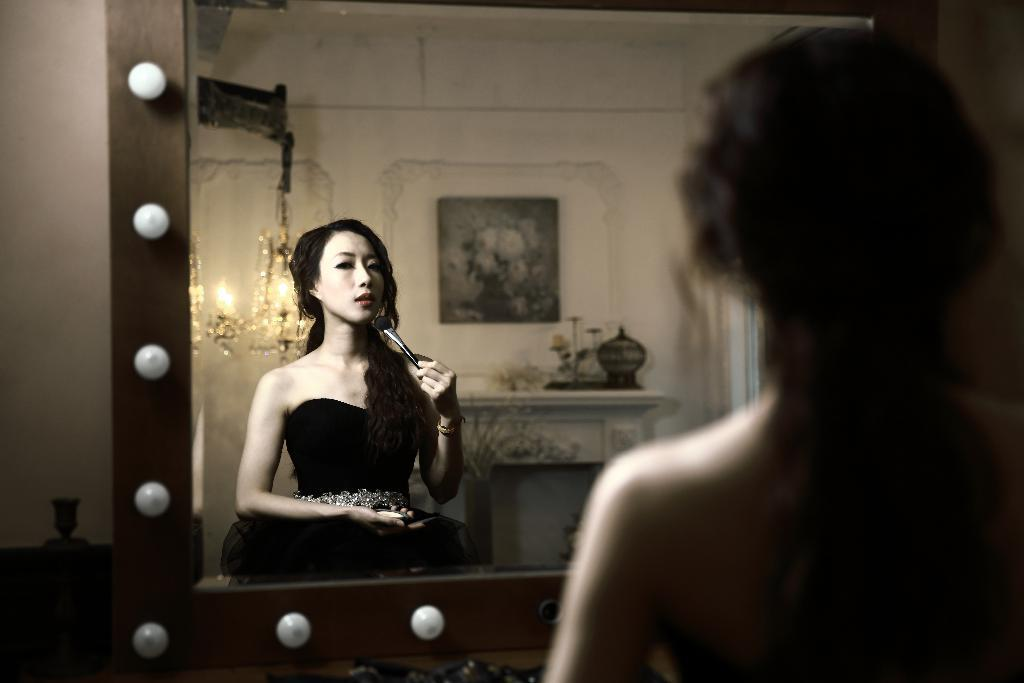What can be seen in the mirror in the image? There is a person's reflection in a mirror in the image. Can you describe the person on the right side of the image? There is a person on the right side of the image. What type of tax is being discussed in the image? There is no discussion of tax in the image; it features a person's reflection in a mirror and a person on the right side of the image. Can you see any harbors in the image? There are no harbors visible in the image. 